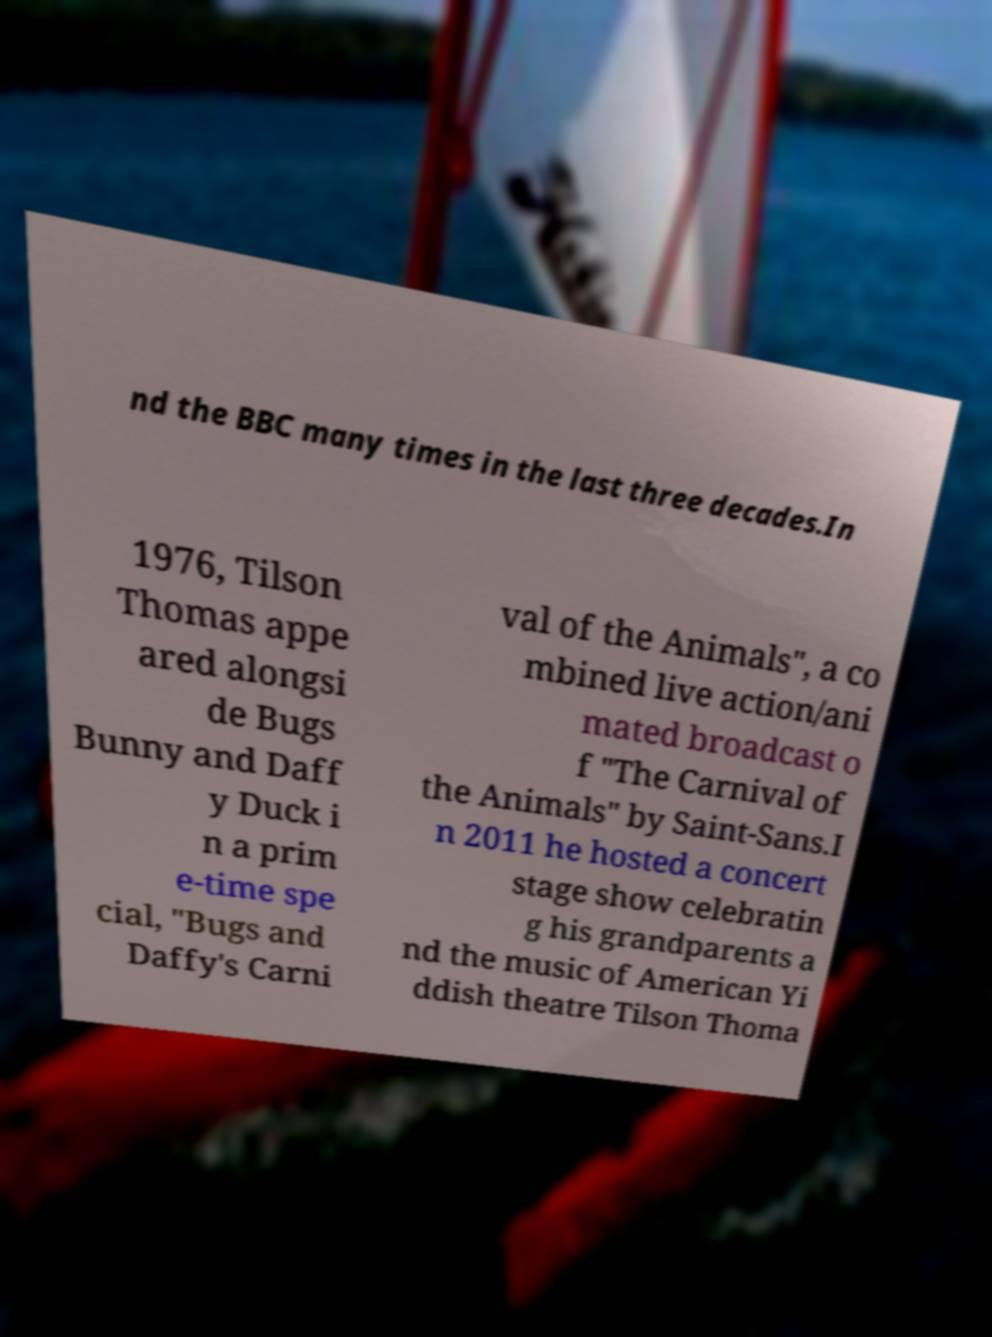There's text embedded in this image that I need extracted. Can you transcribe it verbatim? nd the BBC many times in the last three decades.In 1976, Tilson Thomas appe ared alongsi de Bugs Bunny and Daff y Duck i n a prim e-time spe cial, "Bugs and Daffy's Carni val of the Animals", a co mbined live action/ani mated broadcast o f "The Carnival of the Animals" by Saint-Sans.I n 2011 he hosted a concert stage show celebratin g his grandparents a nd the music of American Yi ddish theatre Tilson Thoma 